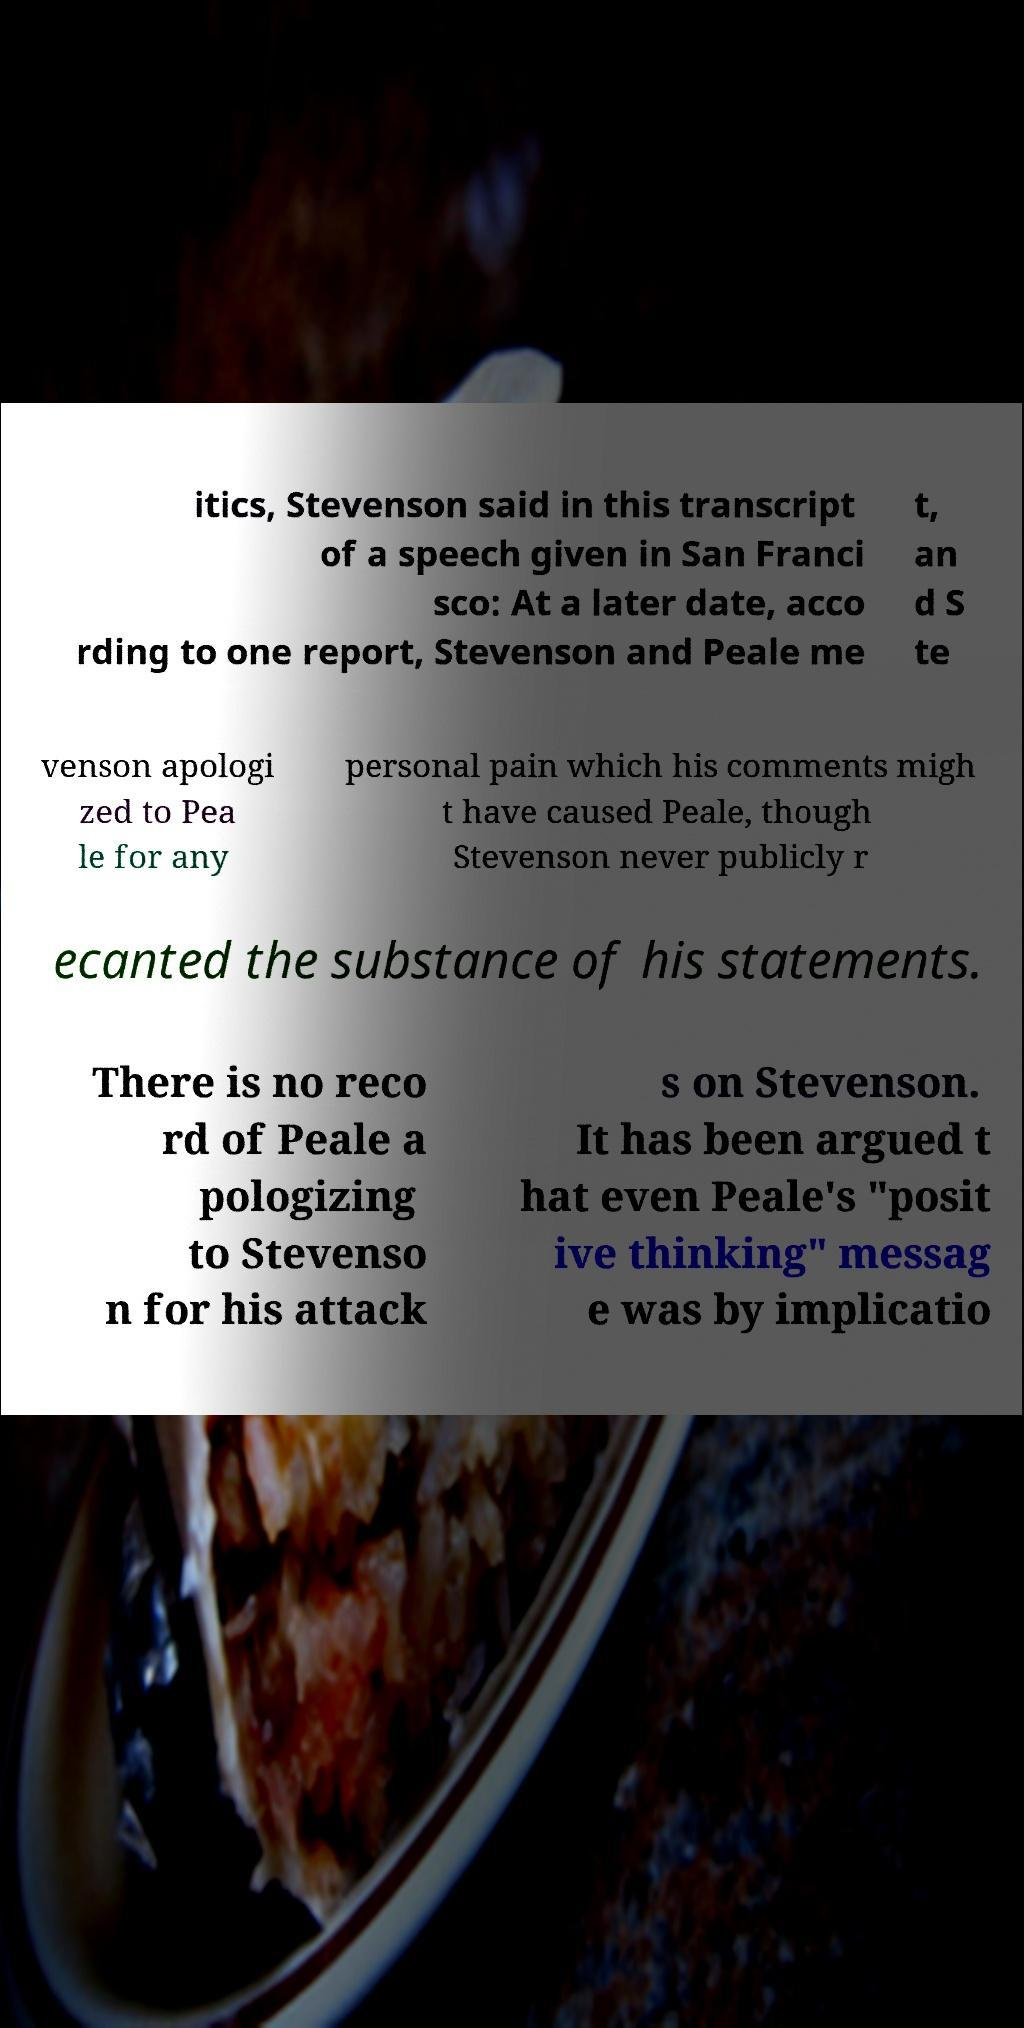Can you read and provide the text displayed in the image?This photo seems to have some interesting text. Can you extract and type it out for me? itics, Stevenson said in this transcript of a speech given in San Franci sco: At a later date, acco rding to one report, Stevenson and Peale me t, an d S te venson apologi zed to Pea le for any personal pain which his comments migh t have caused Peale, though Stevenson never publicly r ecanted the substance of his statements. There is no reco rd of Peale a pologizing to Stevenso n for his attack s on Stevenson. It has been argued t hat even Peale's "posit ive thinking" messag e was by implicatio 